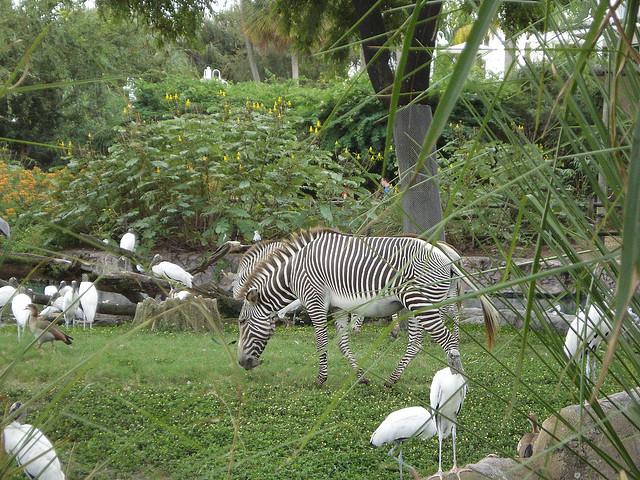Are there any birds?
Give a very brief answer. Yes. What do zebras like to eat?
Be succinct. Grass. Is there a Zebra?
Give a very brief answer. Yes. 